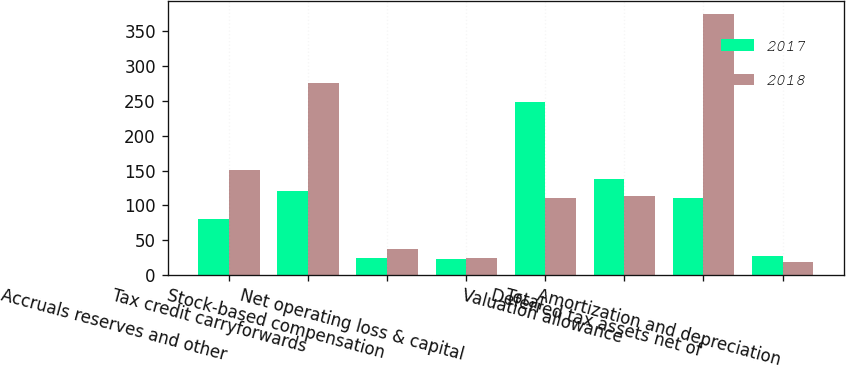<chart> <loc_0><loc_0><loc_500><loc_500><stacked_bar_chart><ecel><fcel>Accruals reserves and other<fcel>Tax credit carryforwards<fcel>Stock-based compensation<fcel>Net operating loss & capital<fcel>Total<fcel>Valuation allowance<fcel>Deferred tax assets net of<fcel>Amortization and depreciation<nl><fcel>2017<fcel>81<fcel>121<fcel>24<fcel>23<fcel>249<fcel>138<fcel>111<fcel>27<nl><fcel>2018<fcel>151<fcel>276<fcel>37<fcel>25<fcel>111<fcel>114<fcel>375<fcel>19<nl></chart> 